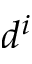Convert formula to latex. <formula><loc_0><loc_0><loc_500><loc_500>d ^ { i }</formula> 